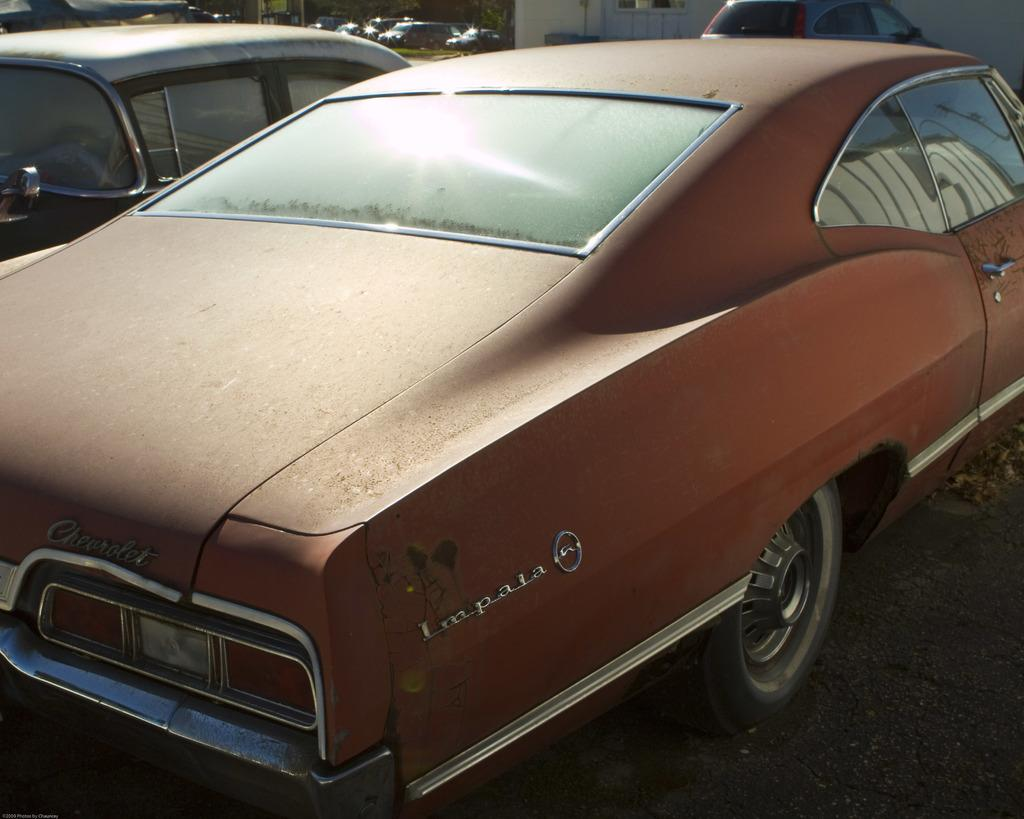What is the main subject in the center of the image? There are cars in the center of the image. What type of animals can be seen at the zoo in the image? There is no zoo present in the image; it features cars in the center. What type of dessert is being served at the cake shop in the image? There is no cake shop present in the image; it features cars in the center. 